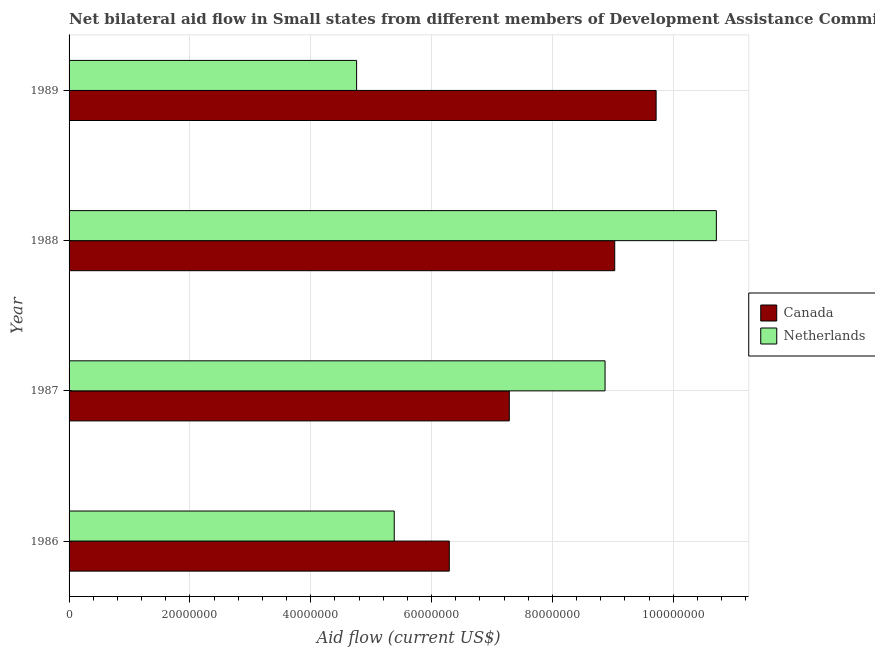How many groups of bars are there?
Your answer should be very brief. 4. How many bars are there on the 4th tick from the top?
Your answer should be compact. 2. What is the label of the 3rd group of bars from the top?
Offer a terse response. 1987. What is the amount of aid given by netherlands in 1987?
Your response must be concise. 8.87e+07. Across all years, what is the maximum amount of aid given by canada?
Offer a terse response. 9.72e+07. Across all years, what is the minimum amount of aid given by netherlands?
Your response must be concise. 4.76e+07. In which year was the amount of aid given by canada maximum?
Offer a terse response. 1989. What is the total amount of aid given by canada in the graph?
Your answer should be compact. 3.23e+08. What is the difference between the amount of aid given by canada in 1988 and that in 1989?
Keep it short and to the point. -6.85e+06. What is the difference between the amount of aid given by netherlands in 1988 and the amount of aid given by canada in 1987?
Your answer should be very brief. 3.43e+07. What is the average amount of aid given by canada per year?
Give a very brief answer. 8.08e+07. In the year 1987, what is the difference between the amount of aid given by canada and amount of aid given by netherlands?
Your answer should be compact. -1.58e+07. What is the ratio of the amount of aid given by netherlands in 1986 to that in 1989?
Offer a very short reply. 1.13. Is the difference between the amount of aid given by netherlands in 1986 and 1989 greater than the difference between the amount of aid given by canada in 1986 and 1989?
Offer a very short reply. Yes. What is the difference between the highest and the second highest amount of aid given by netherlands?
Give a very brief answer. 1.84e+07. What is the difference between the highest and the lowest amount of aid given by canada?
Your answer should be compact. 3.42e+07. In how many years, is the amount of aid given by canada greater than the average amount of aid given by canada taken over all years?
Your answer should be compact. 2. Is the sum of the amount of aid given by netherlands in 1987 and 1989 greater than the maximum amount of aid given by canada across all years?
Make the answer very short. Yes. What does the 1st bar from the top in 1988 represents?
Give a very brief answer. Netherlands. What does the 2nd bar from the bottom in 1989 represents?
Give a very brief answer. Netherlands. How many bars are there?
Your answer should be very brief. 8. Are the values on the major ticks of X-axis written in scientific E-notation?
Offer a terse response. No. How are the legend labels stacked?
Your answer should be compact. Vertical. What is the title of the graph?
Offer a very short reply. Net bilateral aid flow in Small states from different members of Development Assistance Committee. Does "Electricity" appear as one of the legend labels in the graph?
Provide a succinct answer. No. What is the label or title of the X-axis?
Provide a succinct answer. Aid flow (current US$). What is the Aid flow (current US$) of Canada in 1986?
Ensure brevity in your answer.  6.29e+07. What is the Aid flow (current US$) of Netherlands in 1986?
Your answer should be very brief. 5.38e+07. What is the Aid flow (current US$) of Canada in 1987?
Make the answer very short. 7.29e+07. What is the Aid flow (current US$) in Netherlands in 1987?
Your answer should be compact. 8.87e+07. What is the Aid flow (current US$) of Canada in 1988?
Give a very brief answer. 9.03e+07. What is the Aid flow (current US$) of Netherlands in 1988?
Provide a short and direct response. 1.07e+08. What is the Aid flow (current US$) in Canada in 1989?
Provide a short and direct response. 9.72e+07. What is the Aid flow (current US$) of Netherlands in 1989?
Your answer should be compact. 4.76e+07. Across all years, what is the maximum Aid flow (current US$) of Canada?
Your response must be concise. 9.72e+07. Across all years, what is the maximum Aid flow (current US$) of Netherlands?
Offer a very short reply. 1.07e+08. Across all years, what is the minimum Aid flow (current US$) of Canada?
Give a very brief answer. 6.29e+07. Across all years, what is the minimum Aid flow (current US$) in Netherlands?
Your response must be concise. 4.76e+07. What is the total Aid flow (current US$) of Canada in the graph?
Give a very brief answer. 3.23e+08. What is the total Aid flow (current US$) of Netherlands in the graph?
Your answer should be very brief. 2.97e+08. What is the difference between the Aid flow (current US$) in Canada in 1986 and that in 1987?
Offer a very short reply. -9.93e+06. What is the difference between the Aid flow (current US$) of Netherlands in 1986 and that in 1987?
Ensure brevity in your answer.  -3.49e+07. What is the difference between the Aid flow (current US$) in Canada in 1986 and that in 1988?
Offer a very short reply. -2.74e+07. What is the difference between the Aid flow (current US$) in Netherlands in 1986 and that in 1988?
Keep it short and to the point. -5.33e+07. What is the difference between the Aid flow (current US$) in Canada in 1986 and that in 1989?
Make the answer very short. -3.42e+07. What is the difference between the Aid flow (current US$) in Netherlands in 1986 and that in 1989?
Your response must be concise. 6.23e+06. What is the difference between the Aid flow (current US$) of Canada in 1987 and that in 1988?
Make the answer very short. -1.74e+07. What is the difference between the Aid flow (current US$) in Netherlands in 1987 and that in 1988?
Provide a short and direct response. -1.84e+07. What is the difference between the Aid flow (current US$) in Canada in 1987 and that in 1989?
Your response must be concise. -2.43e+07. What is the difference between the Aid flow (current US$) of Netherlands in 1987 and that in 1989?
Your answer should be very brief. 4.11e+07. What is the difference between the Aid flow (current US$) of Canada in 1988 and that in 1989?
Offer a very short reply. -6.85e+06. What is the difference between the Aid flow (current US$) in Netherlands in 1988 and that in 1989?
Offer a terse response. 5.95e+07. What is the difference between the Aid flow (current US$) in Canada in 1986 and the Aid flow (current US$) in Netherlands in 1987?
Provide a short and direct response. -2.58e+07. What is the difference between the Aid flow (current US$) in Canada in 1986 and the Aid flow (current US$) in Netherlands in 1988?
Keep it short and to the point. -4.42e+07. What is the difference between the Aid flow (current US$) in Canada in 1986 and the Aid flow (current US$) in Netherlands in 1989?
Give a very brief answer. 1.53e+07. What is the difference between the Aid flow (current US$) in Canada in 1987 and the Aid flow (current US$) in Netherlands in 1988?
Your answer should be very brief. -3.43e+07. What is the difference between the Aid flow (current US$) of Canada in 1987 and the Aid flow (current US$) of Netherlands in 1989?
Keep it short and to the point. 2.53e+07. What is the difference between the Aid flow (current US$) of Canada in 1988 and the Aid flow (current US$) of Netherlands in 1989?
Give a very brief answer. 4.27e+07. What is the average Aid flow (current US$) of Canada per year?
Offer a very short reply. 8.08e+07. What is the average Aid flow (current US$) of Netherlands per year?
Offer a terse response. 7.43e+07. In the year 1986, what is the difference between the Aid flow (current US$) of Canada and Aid flow (current US$) of Netherlands?
Make the answer very short. 9.11e+06. In the year 1987, what is the difference between the Aid flow (current US$) in Canada and Aid flow (current US$) in Netherlands?
Offer a very short reply. -1.58e+07. In the year 1988, what is the difference between the Aid flow (current US$) of Canada and Aid flow (current US$) of Netherlands?
Ensure brevity in your answer.  -1.68e+07. In the year 1989, what is the difference between the Aid flow (current US$) of Canada and Aid flow (current US$) of Netherlands?
Keep it short and to the point. 4.96e+07. What is the ratio of the Aid flow (current US$) of Canada in 1986 to that in 1987?
Offer a very short reply. 0.86. What is the ratio of the Aid flow (current US$) of Netherlands in 1986 to that in 1987?
Ensure brevity in your answer.  0.61. What is the ratio of the Aid flow (current US$) of Canada in 1986 to that in 1988?
Keep it short and to the point. 0.7. What is the ratio of the Aid flow (current US$) in Netherlands in 1986 to that in 1988?
Provide a short and direct response. 0.5. What is the ratio of the Aid flow (current US$) of Canada in 1986 to that in 1989?
Offer a very short reply. 0.65. What is the ratio of the Aid flow (current US$) of Netherlands in 1986 to that in 1989?
Your answer should be compact. 1.13. What is the ratio of the Aid flow (current US$) in Canada in 1987 to that in 1988?
Your response must be concise. 0.81. What is the ratio of the Aid flow (current US$) in Netherlands in 1987 to that in 1988?
Your response must be concise. 0.83. What is the ratio of the Aid flow (current US$) in Canada in 1987 to that in 1989?
Give a very brief answer. 0.75. What is the ratio of the Aid flow (current US$) of Netherlands in 1987 to that in 1989?
Your response must be concise. 1.86. What is the ratio of the Aid flow (current US$) in Canada in 1988 to that in 1989?
Your answer should be compact. 0.93. What is the ratio of the Aid flow (current US$) of Netherlands in 1988 to that in 1989?
Give a very brief answer. 2.25. What is the difference between the highest and the second highest Aid flow (current US$) of Canada?
Make the answer very short. 6.85e+06. What is the difference between the highest and the second highest Aid flow (current US$) of Netherlands?
Offer a terse response. 1.84e+07. What is the difference between the highest and the lowest Aid flow (current US$) in Canada?
Give a very brief answer. 3.42e+07. What is the difference between the highest and the lowest Aid flow (current US$) in Netherlands?
Offer a very short reply. 5.95e+07. 